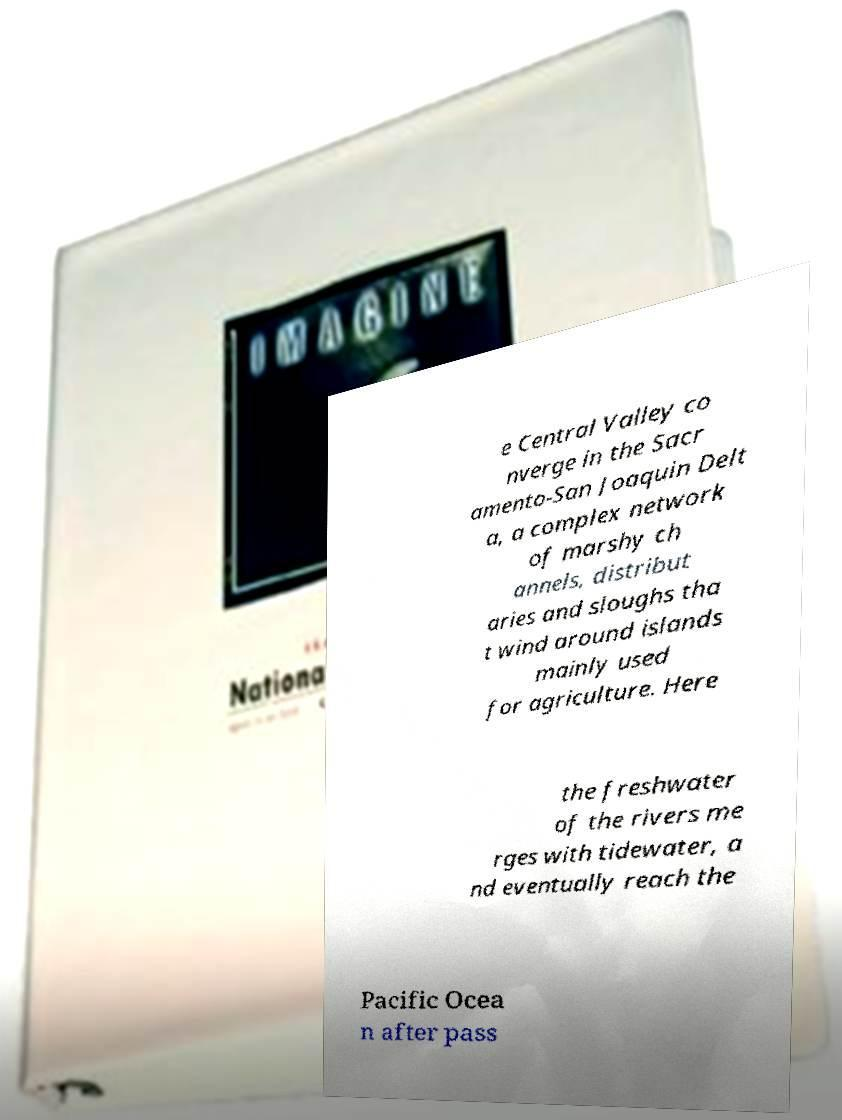Please identify and transcribe the text found in this image. e Central Valley co nverge in the Sacr amento-San Joaquin Delt a, a complex network of marshy ch annels, distribut aries and sloughs tha t wind around islands mainly used for agriculture. Here the freshwater of the rivers me rges with tidewater, a nd eventually reach the Pacific Ocea n after pass 